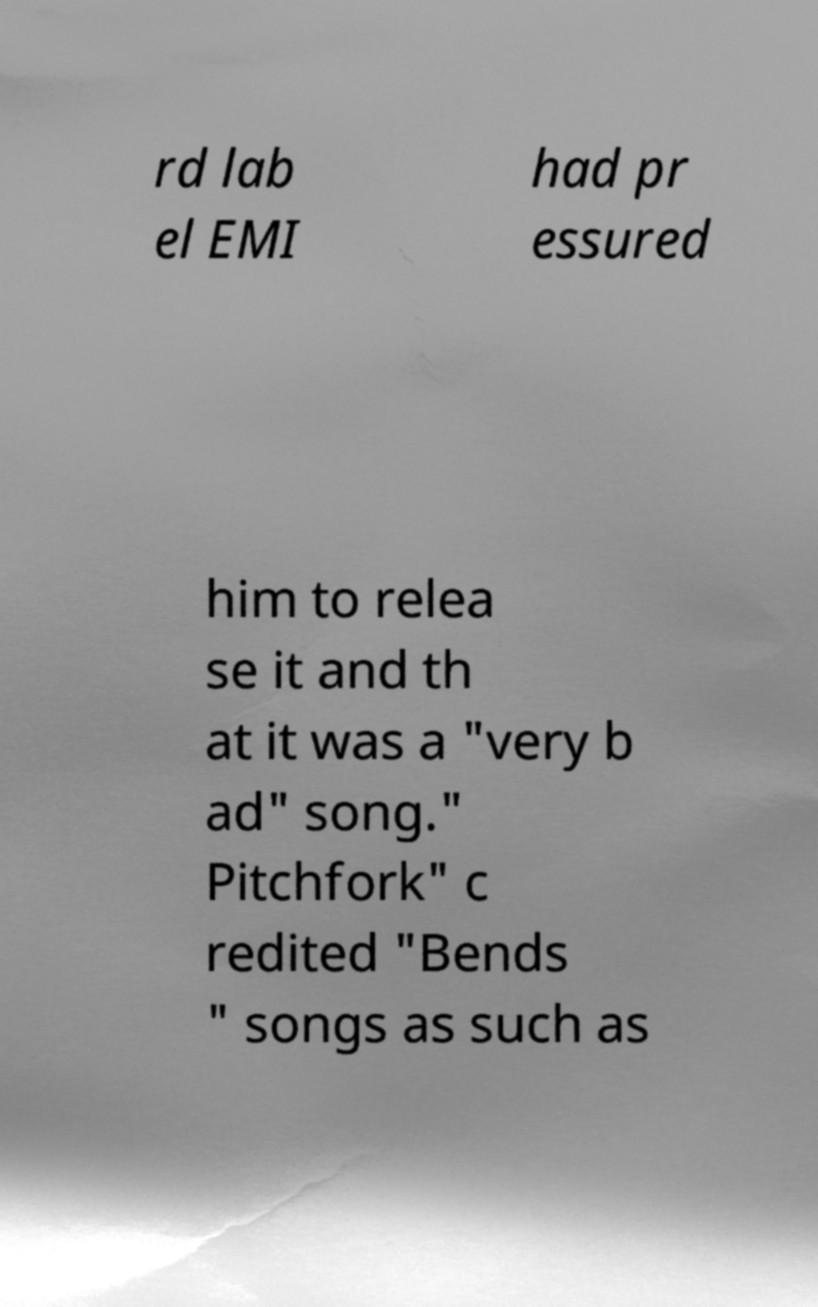What messages or text are displayed in this image? I need them in a readable, typed format. rd lab el EMI had pr essured him to relea se it and th at it was a "very b ad" song." Pitchfork" c redited "Bends " songs as such as 